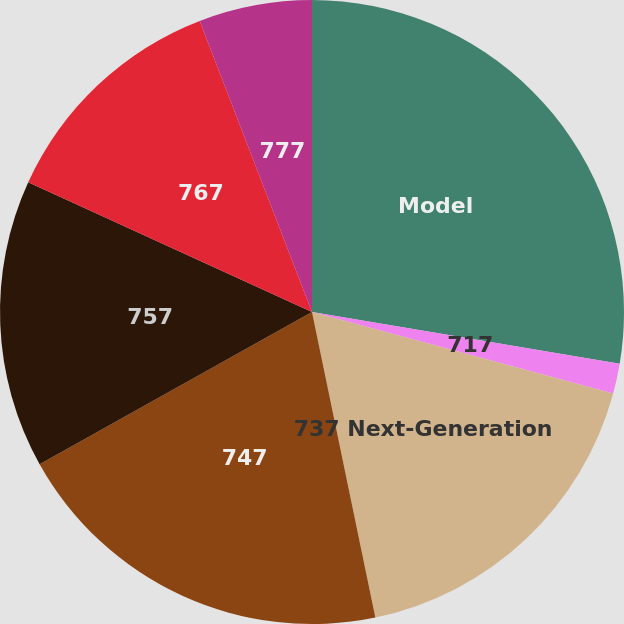Convert chart. <chart><loc_0><loc_0><loc_500><loc_500><pie_chart><fcel>Model<fcel>717<fcel>737 Next-Generation<fcel>747<fcel>757<fcel>767<fcel>777<nl><fcel>27.65%<fcel>1.56%<fcel>17.54%<fcel>20.15%<fcel>14.93%<fcel>12.32%<fcel>5.86%<nl></chart> 